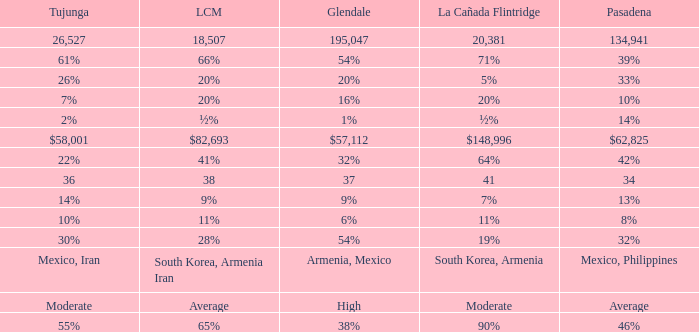What is the figure for Pasadena when Tujunga is 36? 34.0. Could you parse the entire table? {'header': ['Tujunga', 'LCM', 'Glendale', 'La Cañada Flintridge', 'Pasadena'], 'rows': [['26,527', '18,507', '195,047', '20,381', '134,941'], ['61%', '66%', '54%', '71%', '39%'], ['26%', '20%', '20%', '5%', '33%'], ['7%', '20%', '16%', '20%', '10%'], ['2%', '½%', '1%', '½%', '14%'], ['$58,001', '$82,693', '$57,112', '$148,996', '$62,825'], ['22%', '41%', '32%', '64%', '42%'], ['36', '38', '37', '41', '34'], ['14%', '9%', '9%', '7%', '13%'], ['10%', '11%', '6%', '11%', '8%'], ['30%', '28%', '54%', '19%', '32%'], ['Mexico, Iran', 'South Korea, Armenia Iran', 'Armenia, Mexico', 'South Korea, Armenia', 'Mexico, Philippines'], ['Moderate', 'Average', 'High', 'Moderate', 'Average'], ['55%', '65%', '38%', '90%', '46%']]} 